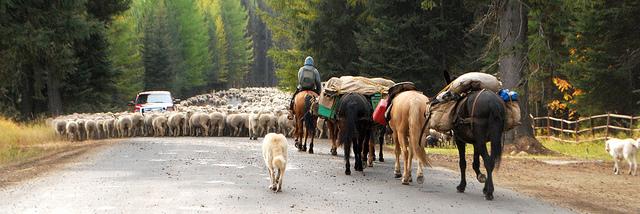What color is the fence?
Write a very short answer. Brown. Are the animals surrounding a vehicle?
Write a very short answer. Yes. Are the horses scared of the sheep?
Give a very brief answer. No. 